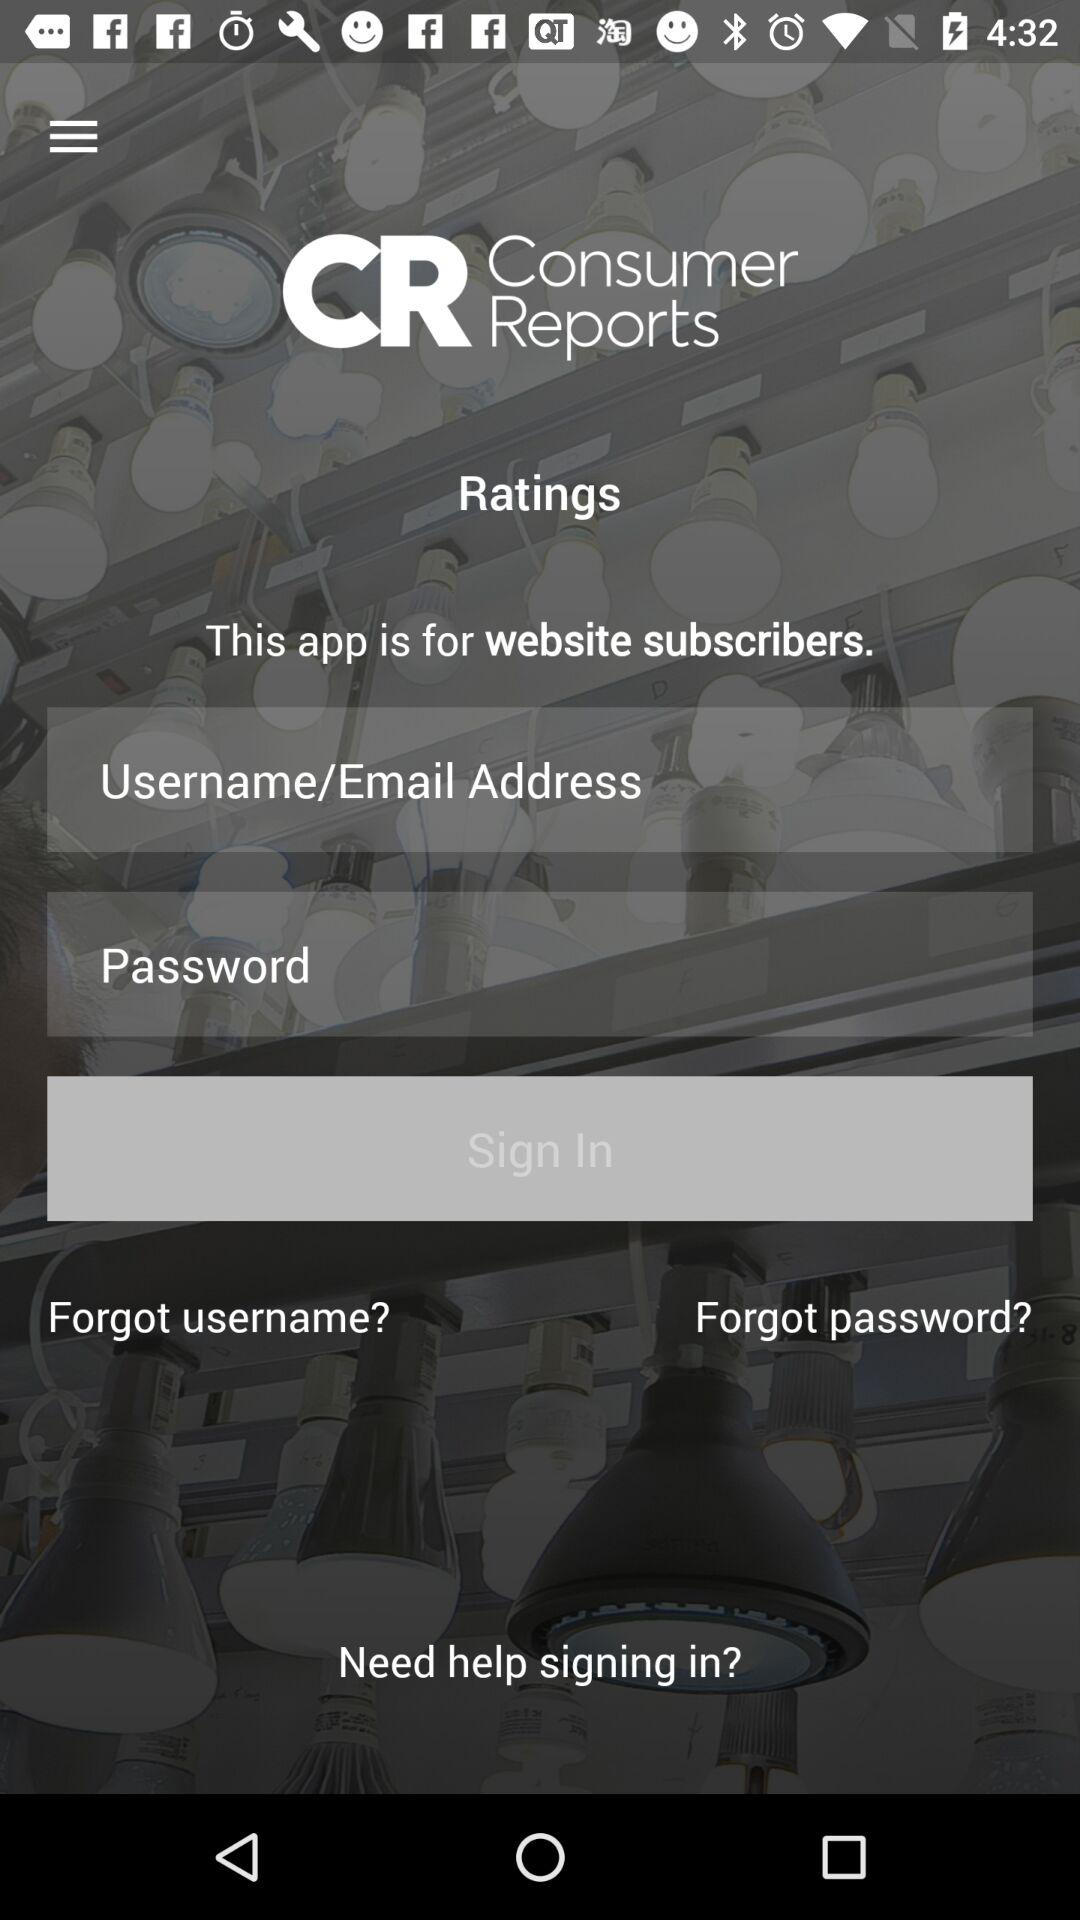How many text inputs are in the sign-in form?
Answer the question using a single word or phrase. 2 